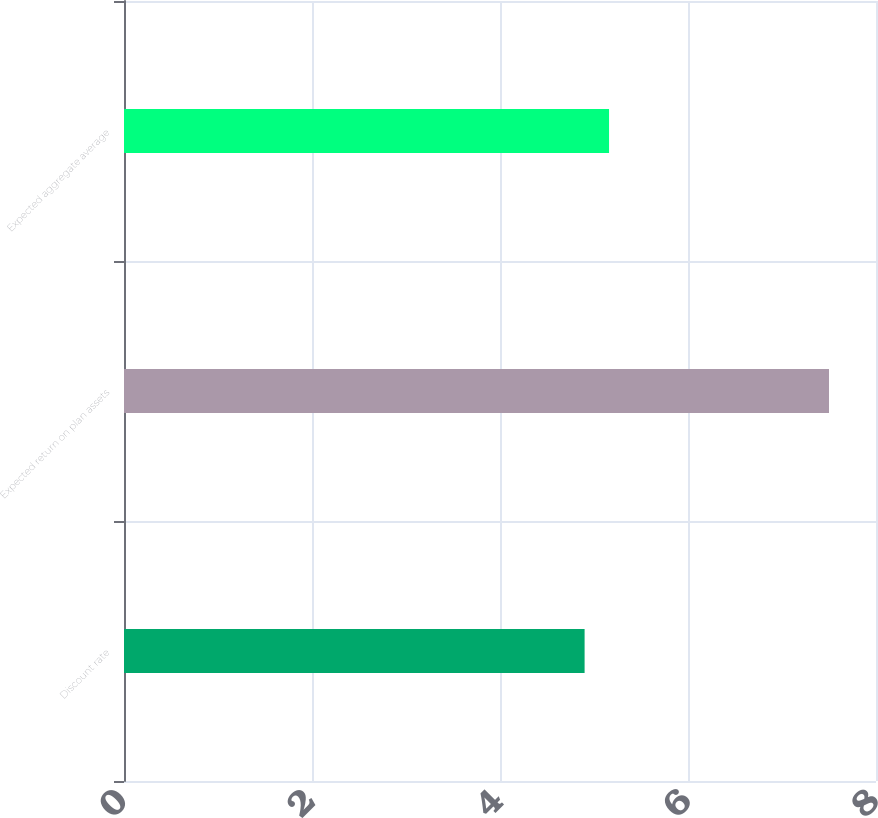Convert chart. <chart><loc_0><loc_0><loc_500><loc_500><bar_chart><fcel>Discount rate<fcel>Expected return on plan assets<fcel>Expected aggregate average<nl><fcel>4.9<fcel>7.5<fcel>5.16<nl></chart> 